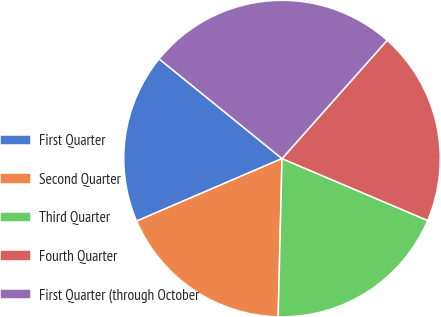Convert chart to OTSL. <chart><loc_0><loc_0><loc_500><loc_500><pie_chart><fcel>First Quarter<fcel>Second Quarter<fcel>Third Quarter<fcel>Fourth Quarter<fcel>First Quarter (through October<nl><fcel>17.31%<fcel>18.15%<fcel>18.99%<fcel>19.83%<fcel>25.71%<nl></chart> 